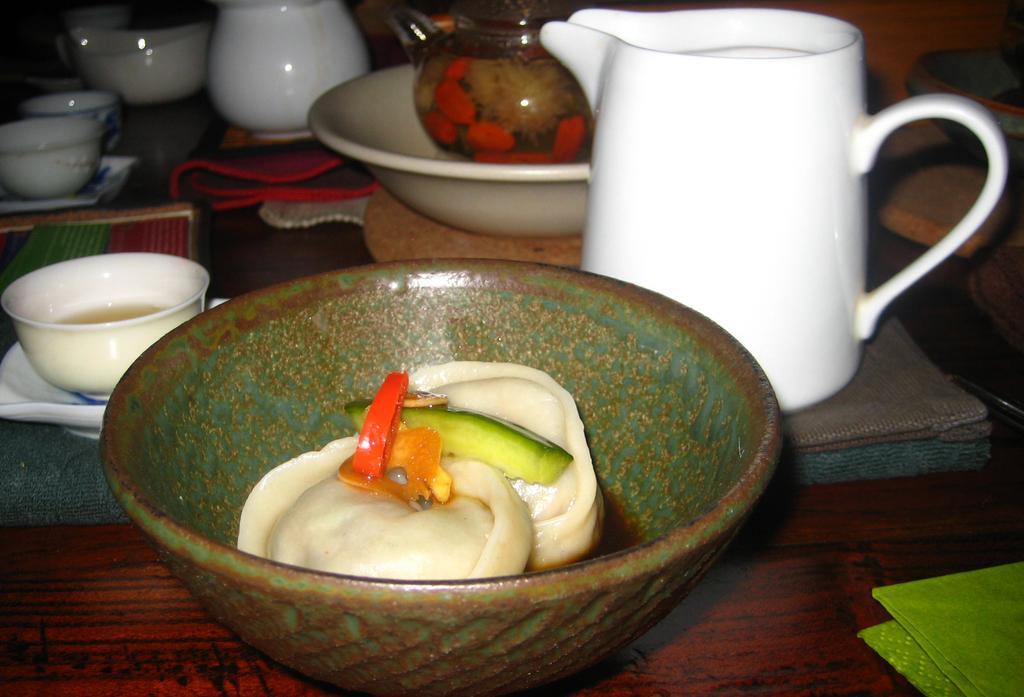How would you summarize this image in a sentence or two? In this picture we can see bowls, teapot, jugs, clothes and in a bowl we can see food items and these all are placed on the wooden surface and in the background we can see some objects. 